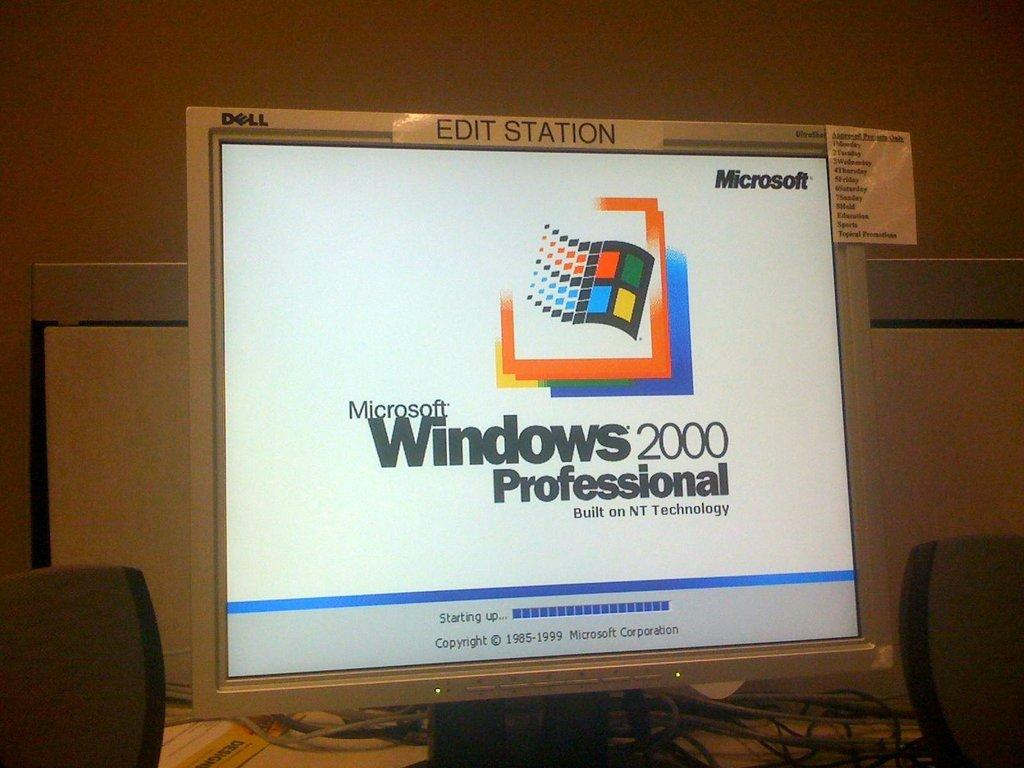<image>
Give a short and clear explanation of the subsequent image. A computer monitor shows that the computer is staring up and running on Windows 2000 Professional edition. 